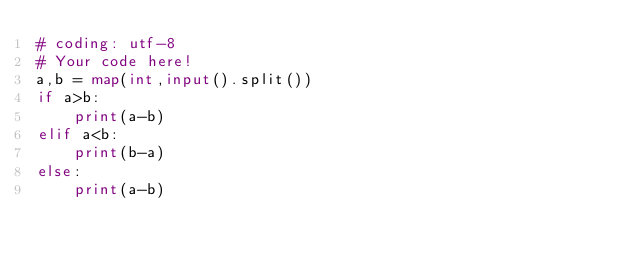Convert code to text. <code><loc_0><loc_0><loc_500><loc_500><_Python_># coding: utf-8
# Your code here!
a,b = map(int,input().split())
if a>b:
    print(a-b)
elif a<b:
    print(b-a)
else:
    print(a-b)
</code> 